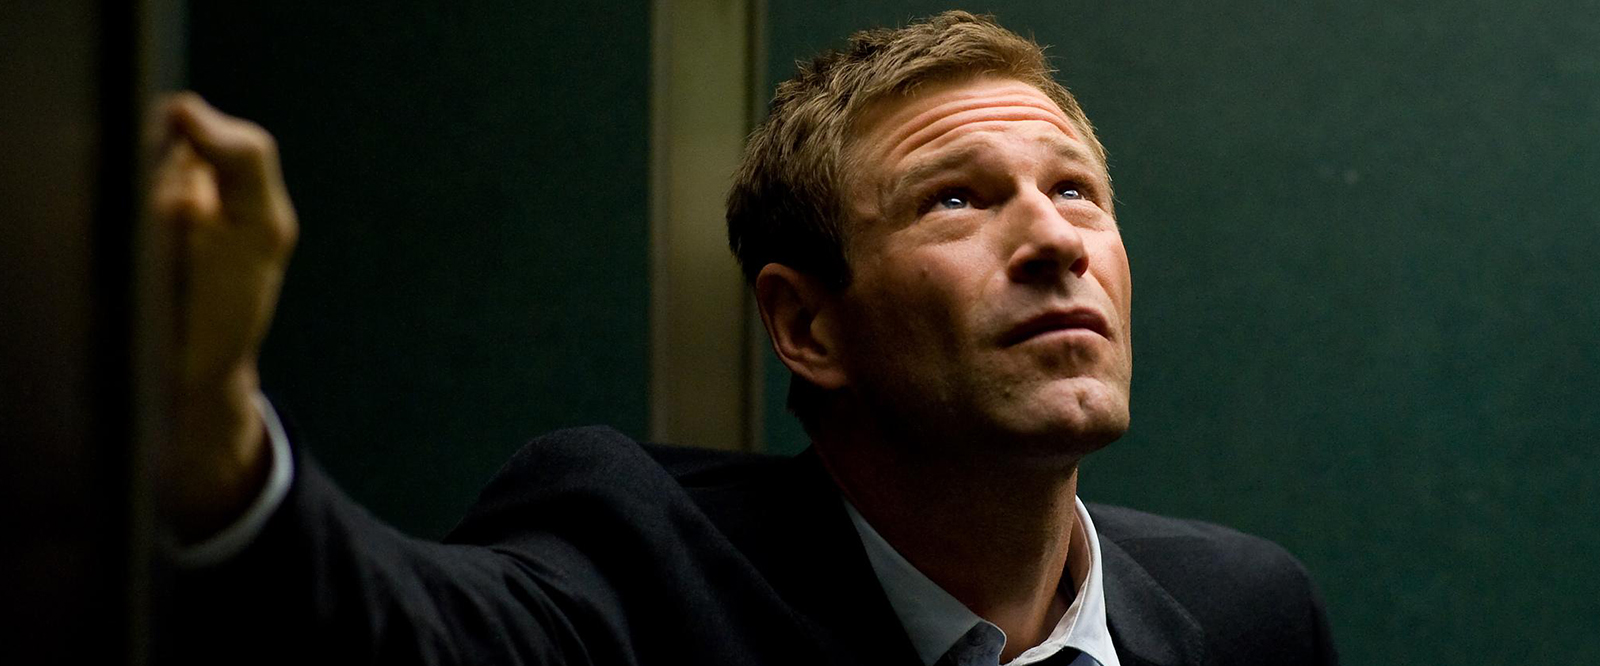Analyze the possible storyline portrayed in this image. The man's attire and posture suggest he could be a professional or businessman caught in a moment of reflection or facing a crucial decision. The minimalistic backdrop provides no distractions, focusing attention on the man's expression. One could imagine a narrative where he is contemplating a significant career move, facing an ethical dilemma, or awaiting crucial news that might impact his life or work. 